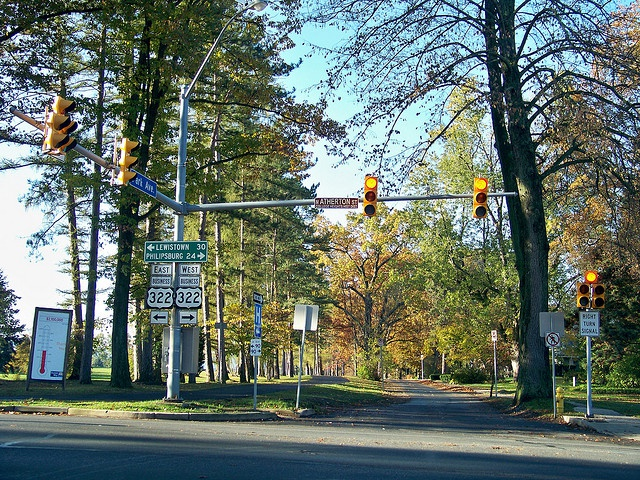Describe the objects in this image and their specific colors. I can see traffic light in black, olive, and white tones, traffic light in black, yellow, olive, and maroon tones, traffic light in black, olive, and white tones, traffic light in black, yellow, maroon, and orange tones, and traffic light in black, olive, and maroon tones in this image. 